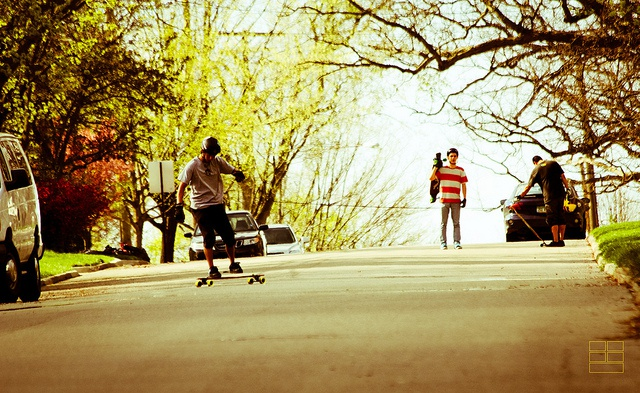Describe the objects in this image and their specific colors. I can see car in maroon, black, tan, and olive tones, people in maroon, black, and gray tones, car in maroon, black, beige, and olive tones, people in maroon, black, and olive tones, and car in maroon, black, and beige tones in this image. 